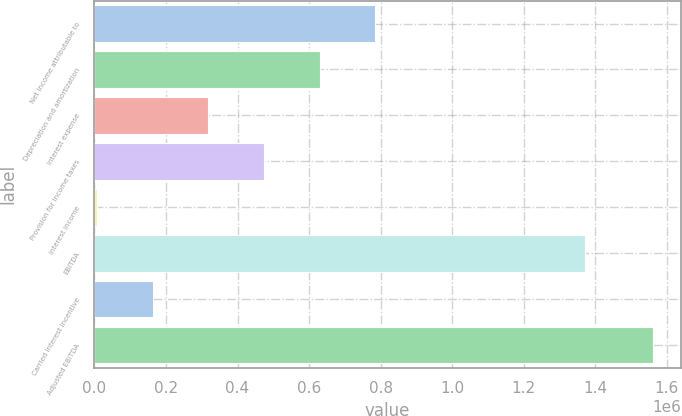Convert chart. <chart><loc_0><loc_0><loc_500><loc_500><bar_chart><fcel>Net income attributable to<fcel>Depreciation and amortization<fcel>Interest expense<fcel>Provision for income taxes<fcel>Interest income<fcel>EBITDA<fcel>Carried interest incentive<fcel>Adjusted EBITDA<nl><fcel>784527<fcel>629232<fcel>318641<fcel>473937<fcel>8051<fcel>1.37236e+06<fcel>163346<fcel>1.561e+06<nl></chart> 